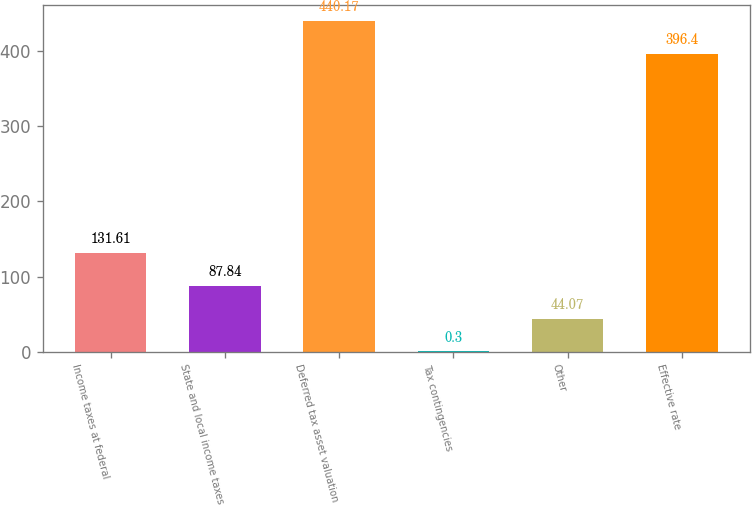Convert chart to OTSL. <chart><loc_0><loc_0><loc_500><loc_500><bar_chart><fcel>Income taxes at federal<fcel>State and local income taxes<fcel>Deferred tax asset valuation<fcel>Tax contingencies<fcel>Other<fcel>Effective rate<nl><fcel>131.61<fcel>87.84<fcel>440.17<fcel>0.3<fcel>44.07<fcel>396.4<nl></chart> 